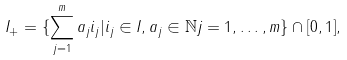Convert formula to latex. <formula><loc_0><loc_0><loc_500><loc_500>I _ { + } = \{ \sum _ { j = 1 } ^ { m } a _ { j } i _ { j } | i _ { j } \in I , a _ { j } \in \mathbb { N } j = 1 , \dots , m \} \cap [ 0 , 1 ] ,</formula> 